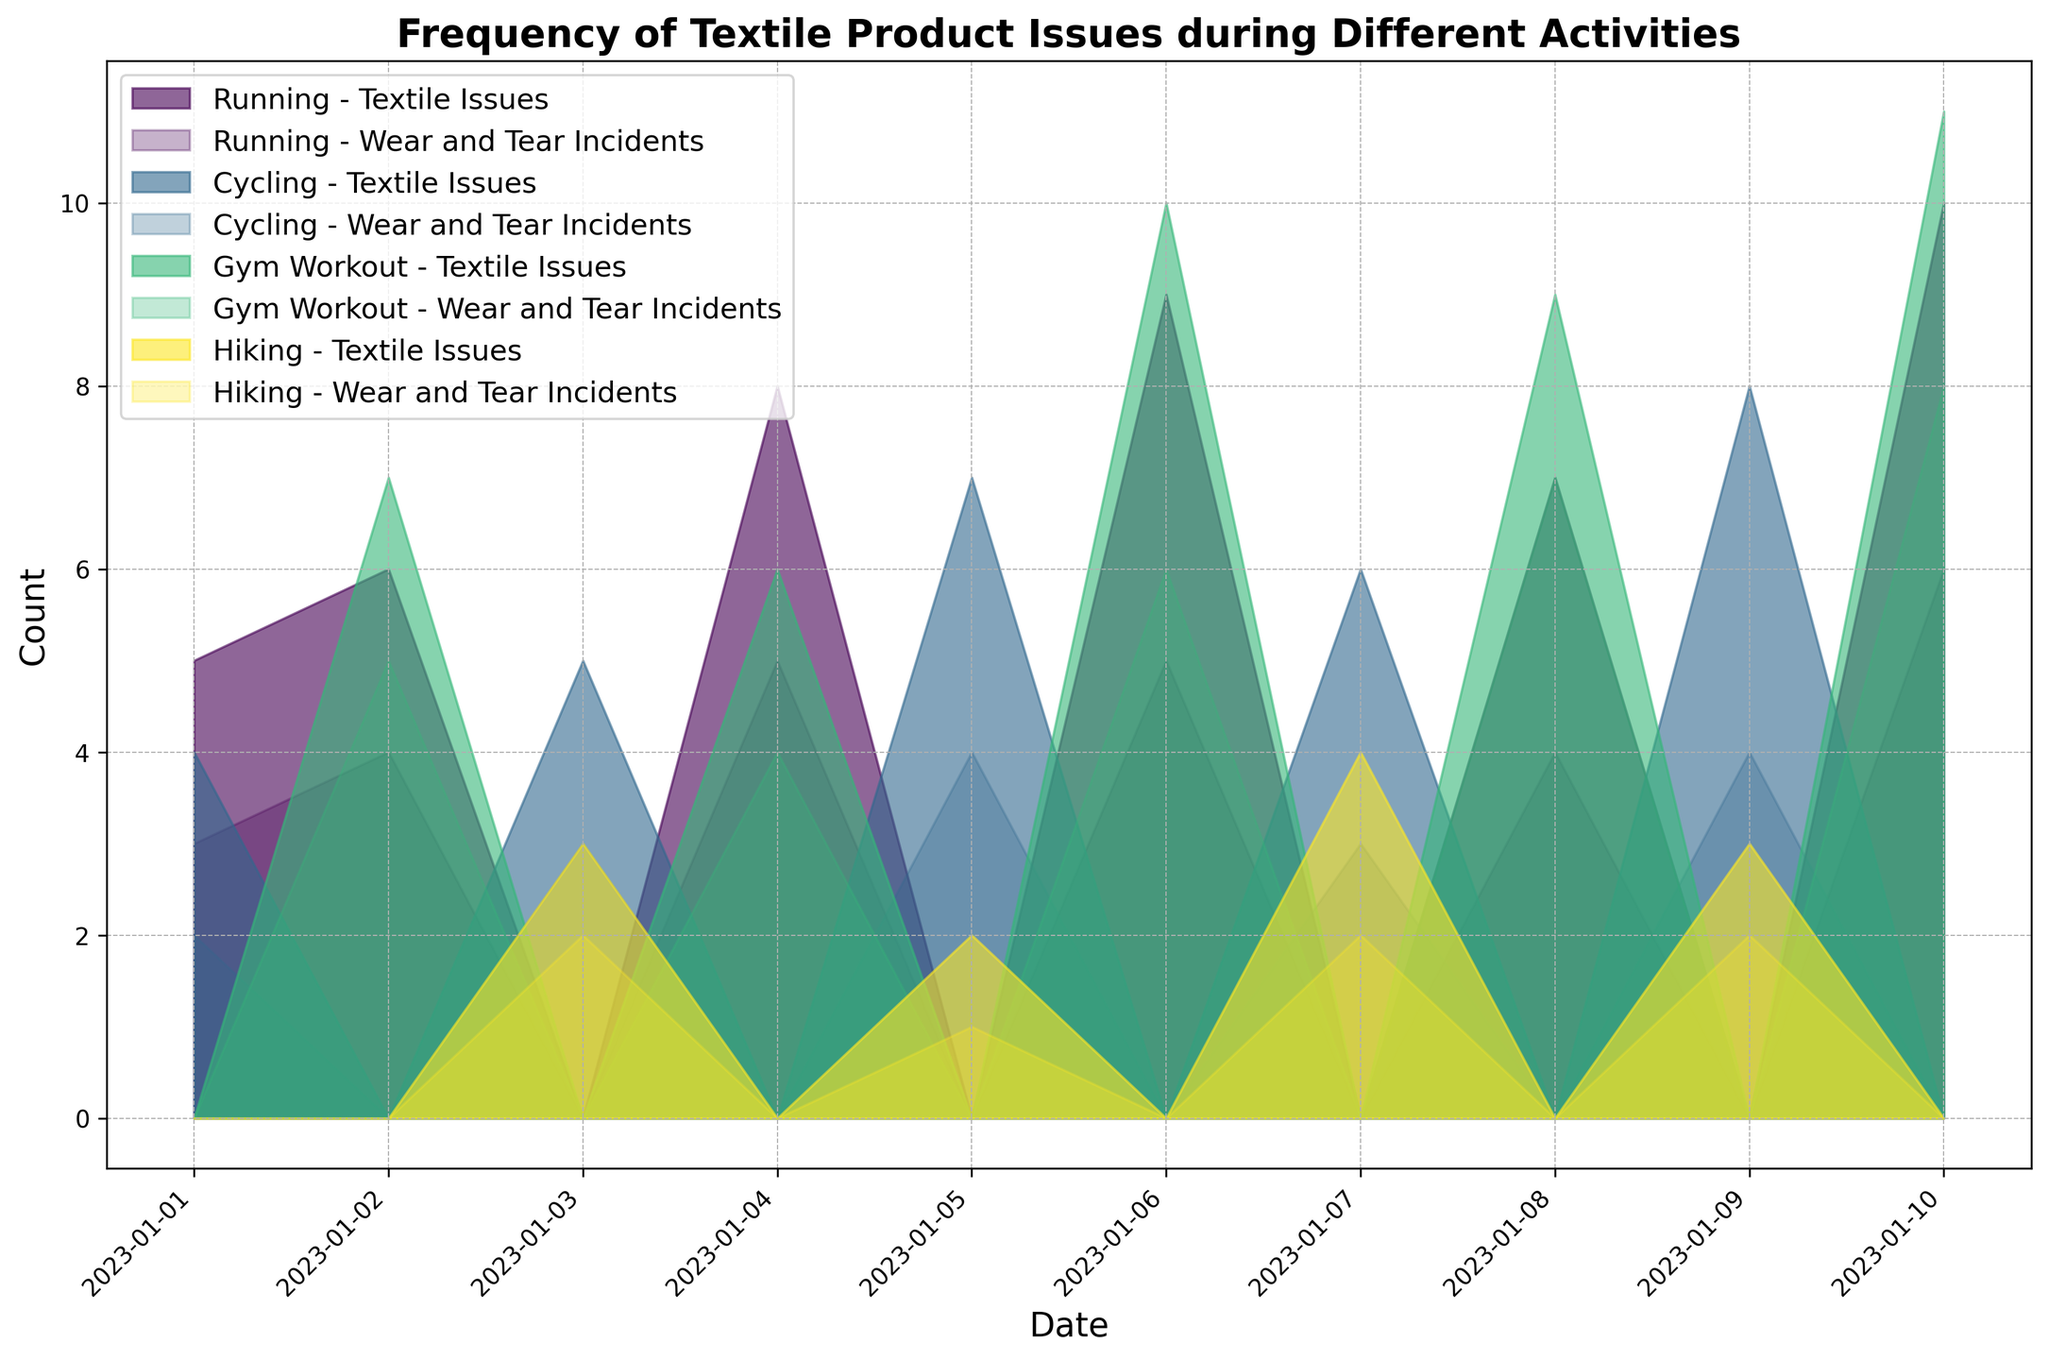Which activity had the highest textile issue count on January 10? On January 10, the activity with the highest textile issue count has the most prominent area. By observing the chart, Gym Workout has the largest area for that date.
Answer: Gym Workout During which activity on January 6 were there more wear and tear incidents compared to textile issues? On January 6, look at the areas for wear and tear incidents and textile issues for each activity. Running has more wear and tear incidents than textile issues.
Answer: Running Which day has the highest overall count of textile issues across all activities? By examining the height of the stacked areas for each day, January 10 shows the highest overall count of textile issues across all activities.
Answer: January 10 What is the difference in textile issue counts between Gym Workout and Hiking on January 5? On January 5, Hiking has a textile issue count area height of 2, and Gym Workout has none. Therefore, the difference is 2.
Answer: 2 What is the total count of wear and tear incidents for Running over all days shown in the chart? Sum the wear and tear incidents for Running on the dates it appears: 3 (Jan 1) + 4 (Jan 2) + 5 (Jan 4) + 5 (Jan 6) + 4 (Jan 8) + 6 (Jan 10). The sum is 27.
Answer: 27 Which activity showed the least variability in textile issue counts over the days? The least variability is observed by noticing the flatter areas over the days. Hiking generally shows the most consistent and least variable counts compared to other activities.
Answer: Hiking On which date did Cycling have more textile issues than Gym Workout, but fewer wear and tear incidents? Look at the dates where both activities are recorded. On January 2, Cycling (4 textile issues, 2 wear and tear) has more textile issues but fewer wear and tear incidents compared to Gym Workout (7 textile issues, 5 wear and tear).
Answer: January 2 What is the combined total of textile issue counts for all activities on January 4? Sum the textile issue counts on January 4 for all activities: Running (8) + Gym Workout (6). The combined total is 14.
Answer: 14 